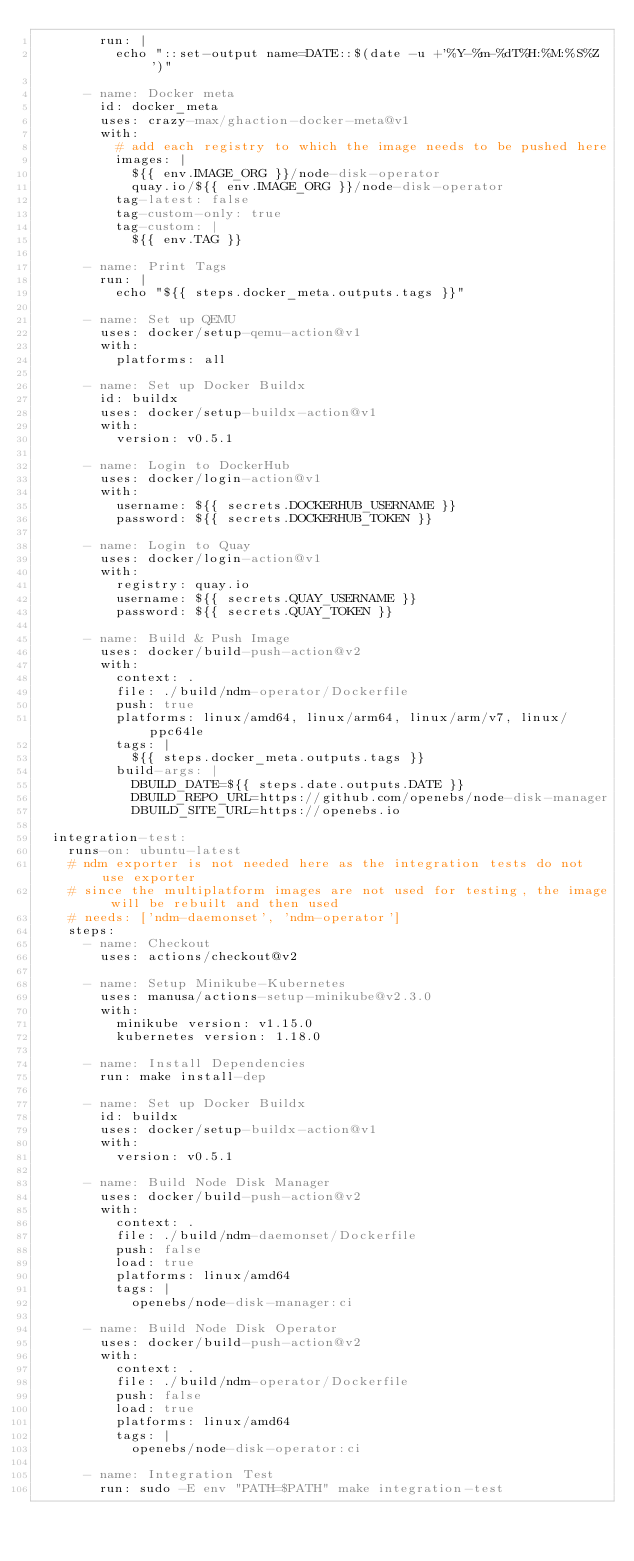<code> <loc_0><loc_0><loc_500><loc_500><_YAML_>        run: |
          echo "::set-output name=DATE::$(date -u +'%Y-%m-%dT%H:%M:%S%Z')"

      - name: Docker meta
        id: docker_meta
        uses: crazy-max/ghaction-docker-meta@v1
        with:
          # add each registry to which the image needs to be pushed here
          images: |
            ${{ env.IMAGE_ORG }}/node-disk-operator
            quay.io/${{ env.IMAGE_ORG }}/node-disk-operator
          tag-latest: false
          tag-custom-only: true
          tag-custom: |
            ${{ env.TAG }}

      - name: Print Tags
        run: |
          echo "${{ steps.docker_meta.outputs.tags }}"

      - name: Set up QEMU
        uses: docker/setup-qemu-action@v1
        with:
          platforms: all

      - name: Set up Docker Buildx
        id: buildx
        uses: docker/setup-buildx-action@v1
        with:
          version: v0.5.1

      - name: Login to DockerHub
        uses: docker/login-action@v1
        with:
          username: ${{ secrets.DOCKERHUB_USERNAME }}
          password: ${{ secrets.DOCKERHUB_TOKEN }}

      - name: Login to Quay
        uses: docker/login-action@v1
        with:
          registry: quay.io
          username: ${{ secrets.QUAY_USERNAME }}
          password: ${{ secrets.QUAY_TOKEN }}

      - name: Build & Push Image
        uses: docker/build-push-action@v2
        with:
          context: .
          file: ./build/ndm-operator/Dockerfile
          push: true
          platforms: linux/amd64, linux/arm64, linux/arm/v7, linux/ppc64le
          tags: |
            ${{ steps.docker_meta.outputs.tags }}
          build-args: |
            DBUILD_DATE=${{ steps.date.outputs.DATE }}
            DBUILD_REPO_URL=https://github.com/openebs/node-disk-manager
            DBUILD_SITE_URL=https://openebs.io

  integration-test:
    runs-on: ubuntu-latest
    # ndm exporter is not needed here as the integration tests do not use exporter
    # since the multiplatform images are not used for testing, the image will be rebuilt and then used
    # needs: ['ndm-daemonset', 'ndm-operator']
    steps:
      - name: Checkout
        uses: actions/checkout@v2

      - name: Setup Minikube-Kubernetes
        uses: manusa/actions-setup-minikube@v2.3.0
        with:
          minikube version: v1.15.0
          kubernetes version: 1.18.0

      - name: Install Dependencies
        run: make install-dep

      - name: Set up Docker Buildx
        id: buildx
        uses: docker/setup-buildx-action@v1
        with:
          version: v0.5.1

      - name: Build Node Disk Manager
        uses: docker/build-push-action@v2
        with:
          context: .
          file: ./build/ndm-daemonset/Dockerfile
          push: false
          load: true
          platforms: linux/amd64
          tags: |
            openebs/node-disk-manager:ci

      - name: Build Node Disk Operator
        uses: docker/build-push-action@v2
        with:
          context: .
          file: ./build/ndm-operator/Dockerfile
          push: false
          load: true
          platforms: linux/amd64
          tags: |
            openebs/node-disk-operator:ci

      - name: Integration Test
        run: sudo -E env "PATH=$PATH" make integration-test
</code> 